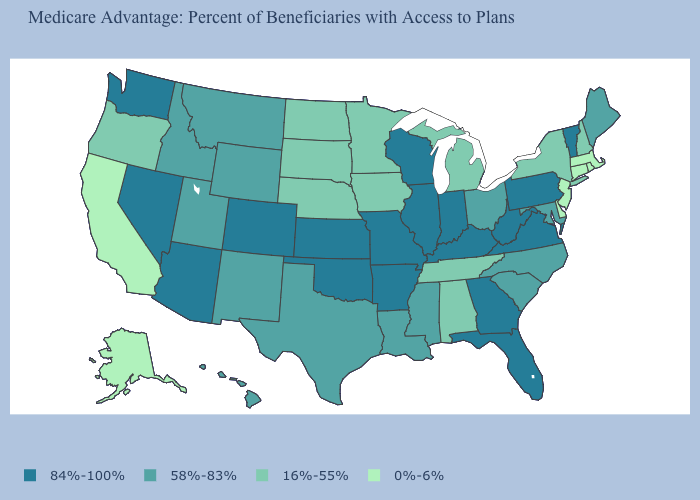Which states have the highest value in the USA?
Short answer required. Arkansas, Arizona, Colorado, Florida, Georgia, Illinois, Indiana, Kansas, Kentucky, Missouri, Nevada, Oklahoma, Pennsylvania, Virginia, Vermont, Washington, Wisconsin, West Virginia. Name the states that have a value in the range 16%-55%?
Concise answer only. Alabama, Iowa, Michigan, Minnesota, North Dakota, Nebraska, New Hampshire, New York, Oregon, South Dakota, Tennessee. What is the value of Massachusetts?
Concise answer only. 0%-6%. What is the value of Ohio?
Quick response, please. 58%-83%. Does Montana have a lower value than Kansas?
Give a very brief answer. Yes. Name the states that have a value in the range 84%-100%?
Be succinct. Arkansas, Arizona, Colorado, Florida, Georgia, Illinois, Indiana, Kansas, Kentucky, Missouri, Nevada, Oklahoma, Pennsylvania, Virginia, Vermont, Washington, Wisconsin, West Virginia. Among the states that border Michigan , which have the highest value?
Give a very brief answer. Indiana, Wisconsin. Name the states that have a value in the range 16%-55%?
Keep it brief. Alabama, Iowa, Michigan, Minnesota, North Dakota, Nebraska, New Hampshire, New York, Oregon, South Dakota, Tennessee. What is the value of Pennsylvania?
Answer briefly. 84%-100%. Which states have the lowest value in the USA?
Be succinct. Alaska, California, Connecticut, Delaware, Massachusetts, New Jersey, Rhode Island. Which states have the lowest value in the South?
Give a very brief answer. Delaware. Among the states that border Washington , which have the highest value?
Keep it brief. Idaho. What is the highest value in states that border Tennessee?
Keep it brief. 84%-100%. Which states have the lowest value in the USA?
Keep it brief. Alaska, California, Connecticut, Delaware, Massachusetts, New Jersey, Rhode Island. What is the highest value in states that border Oklahoma?
Concise answer only. 84%-100%. 